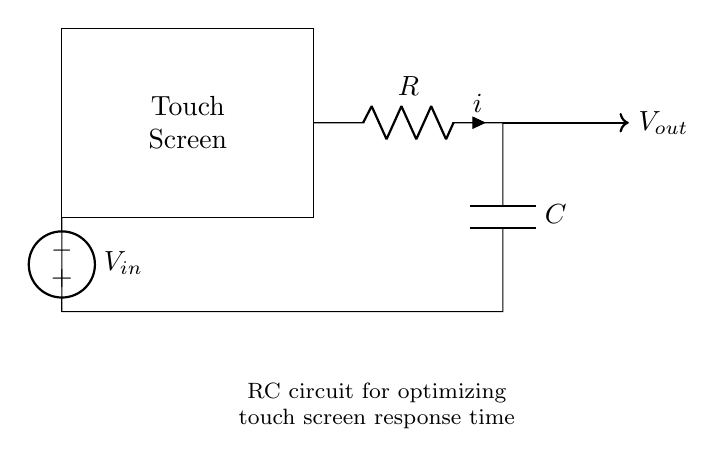What are the components of this circuit? The circuit contains a resistor, a capacitor, a voltage source, and a touch screen. These components are clearly marked in the diagram, with the resistor labeled as R, the capacitor as C, the voltage source as V, and the touch screen as a rectangular box.
Answer: Resistor, Capacitor, Voltage Source, Touch Screen What is the purpose of the capacitor in this circuit? The capacitor's role is to store charge and smooth out fluctuations in voltage, which can optimize the response time of the touch screen. In an RC circuit, the capacitor helps in filtering and timing, providing a stable voltage to the touch screen for improved performance.
Answer: Smooth voltage fluctuations What is the output of the circuit labeled as? The output of the circuit is labeled as Vout, which represents the voltage that will be measured across the output node of the RC circuit. This indicates that it is the resultant voltage after the interaction of the input voltage, resistor, and capacitor.
Answer: Vout How does the resistor influence the charging time of the capacitor? The resistor affects the charging time of the capacitor according to the time constant formula (tau = R*C). This time constant determines how quickly the capacitor charges to approximately 63 percent of the supply voltage. A larger resistor value results in a longer charging time, thus influencing the responsiveness of the touch screen.
Answer: It increases charging time What is the input voltage for this circuit? The input voltage is labeled as Vin, which indicates the voltage supplied to the RC circuit from the voltage source to power the touch screen. The input voltage value depends on the specific design of the circuit but is crucial for determining the effective operation of the components.
Answer: Vin What happens when the touch screen is activated? When the touch screen is activated, a voltage signal is applied, causing the capacitor to charge through the resistor. This charging behavior leads to a change in voltage across the output, which can then be interpreted by the touchscreen controller to register a touch event. This rapid voltage change is essential for optimizing response time.
Answer: Capacitor charges; voltage change What is the significance of optimizing the touch screen response time? Optimizing the response time is crucial for enhancing user experience on touch devices. Faster response times mean more immediate feedback to user interactions, which improves usability and satisfaction. In applications such as gaming or touch-based controls, quick response times are particularly important for performance.
Answer: Enhances user experience 